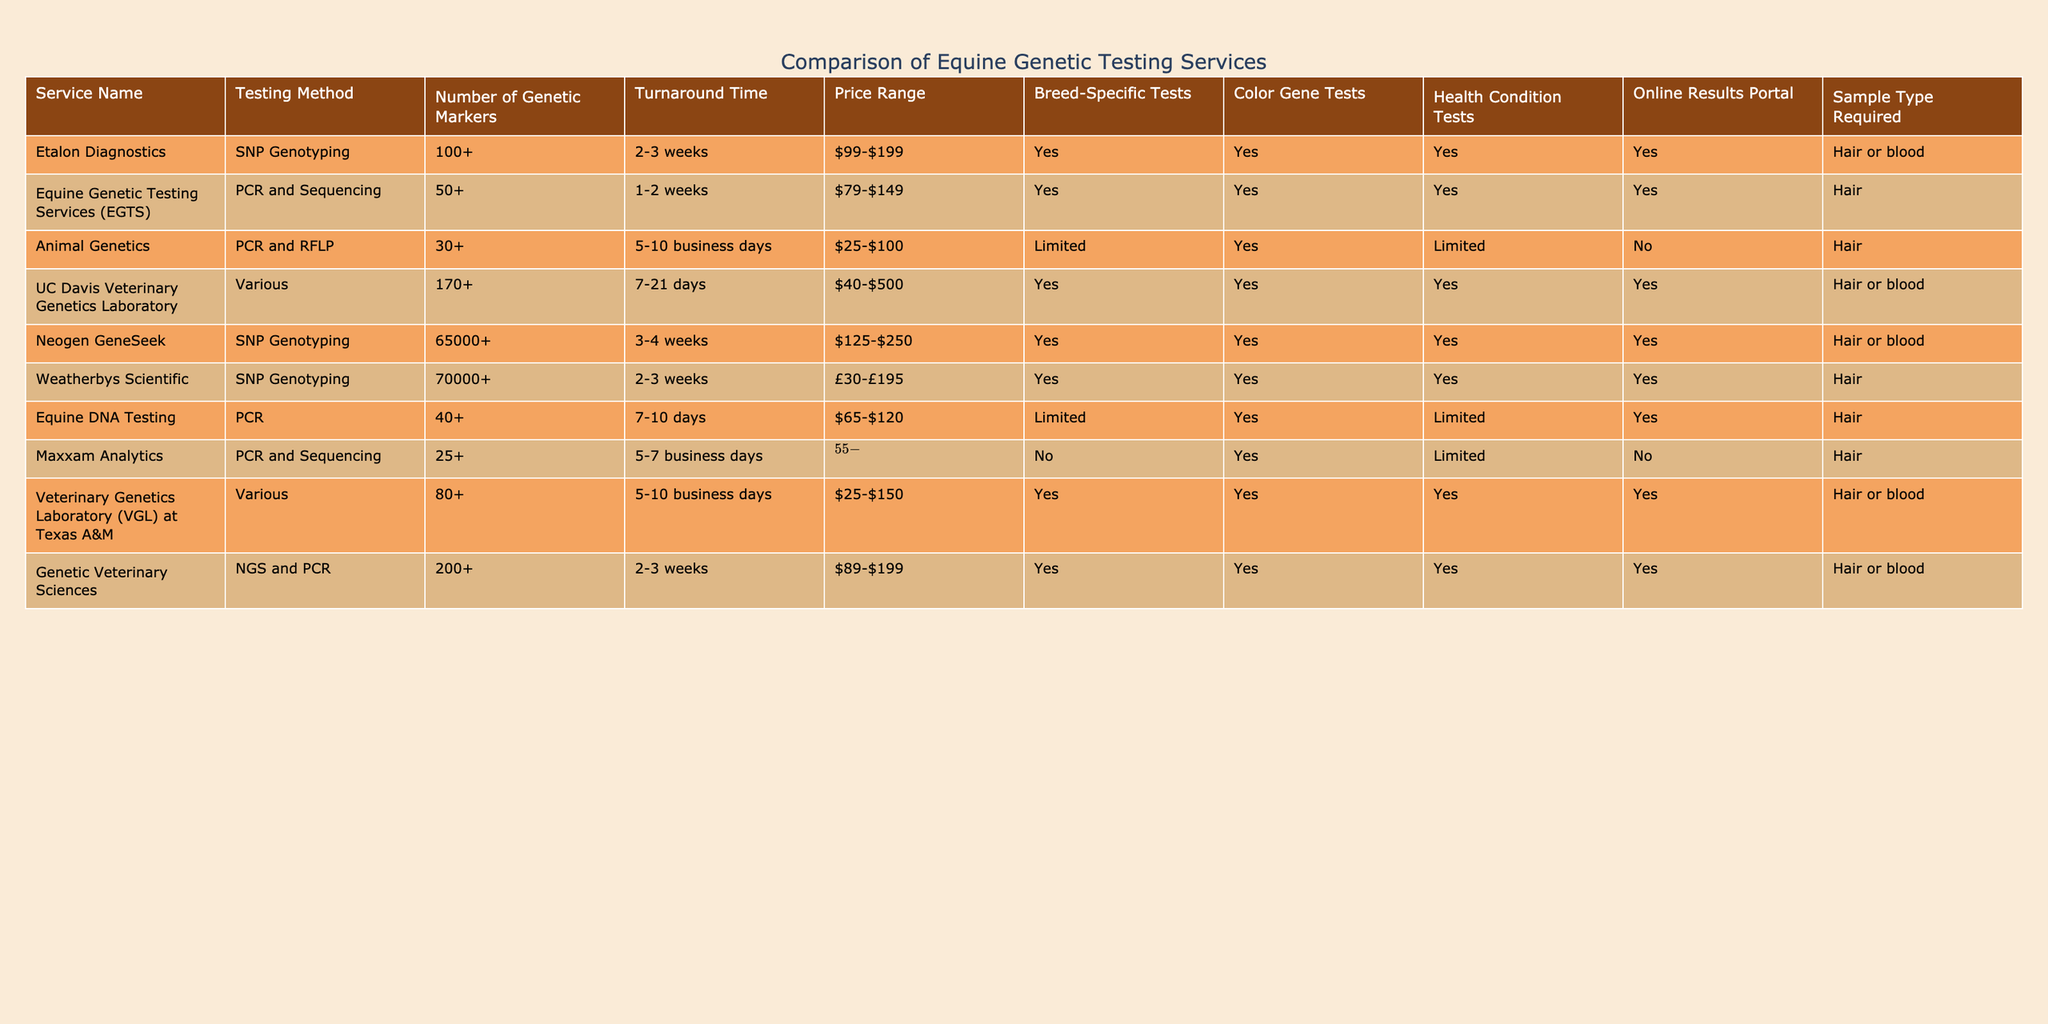What is the service with the highest number of genetic markers? By reviewing the "Number of Genetic Markers" column, Neogen GeneSeek has 65000+ markers, which is the highest among all services listed.
Answer: Neogen GeneSeek Which services offer breed-specific tests? Looking at the "Breed-Specific Tests" column, the services that provide this option are Etalon Diagnostics, UC Davis Veterinary Genetics Laboratory, Neogen GeneSeek, Weatherbys Scientific, Veterinary Genetics Laboratory at Texas A&M, and Genetic Veterinary Sciences.
Answer: Yes What is the price range of the Animal Genetics service? Referring to the "Price Range" column for Animal Genetics, it is listed as $25-$100.
Answer: $25-$100 How long does it typically take for the Genetic Veterinary Sciences to provide results? Checking the "Turnaround Time" column for Genetic Veterinary Sciences, it states 2-3 weeks to receive the results.
Answer: 2-3 weeks Which service provides an online results portal and uses blood as a sample type? The "Online Results Portal" column shows "Yes" for the services: Etalon Diagnostics, UC Davis Veterinary Genetics Laboratory, Neogen GeneSeek, Weatherbys Scientific, Veterinary Genetics Laboratory at Texas A&M, and Genetic Veterinary Sciences. Among these, the ones that also accept blood as a sample type are Etalon Diagnostics, UC Davis Veterinary Genetics Laboratory, and Veterinary Genetics Laboratory at Texas A&M.
Answer: 3 What is the average number of genetic markers for the services that use SNP Genotyping? The services using SNP Genotyping are: Etalon Diagnostics (100+), Neogen GeneSeek (65000+), Weatherbys Scientific (70000+). Combining these gives a rough average of (100 + 65000 + 70000) / 3 = 21667 (approximating 100+ as 100).
Answer: 21667 Are there any services that do not provide health condition tests? Referring to the "Health Condition Tests" column, Animal Genetics and Maxxam Analytics show "Limited" and "No", indicating they do not fully provide health condition tests as others do.
Answer: Yes What is the price range of the service with the longest turnaround time? The "Turnaround Time" for the UC Davis Veterinary Genetics Laboratory is 7-21 days, which is the longest. Its price range is $40-$500.
Answer: $40-$500 Which service has the lowest price range for genetic testing? Per the "Price Range" column, Animal Genetics has the lowest price range at $25-$100.
Answer: $25-$100 